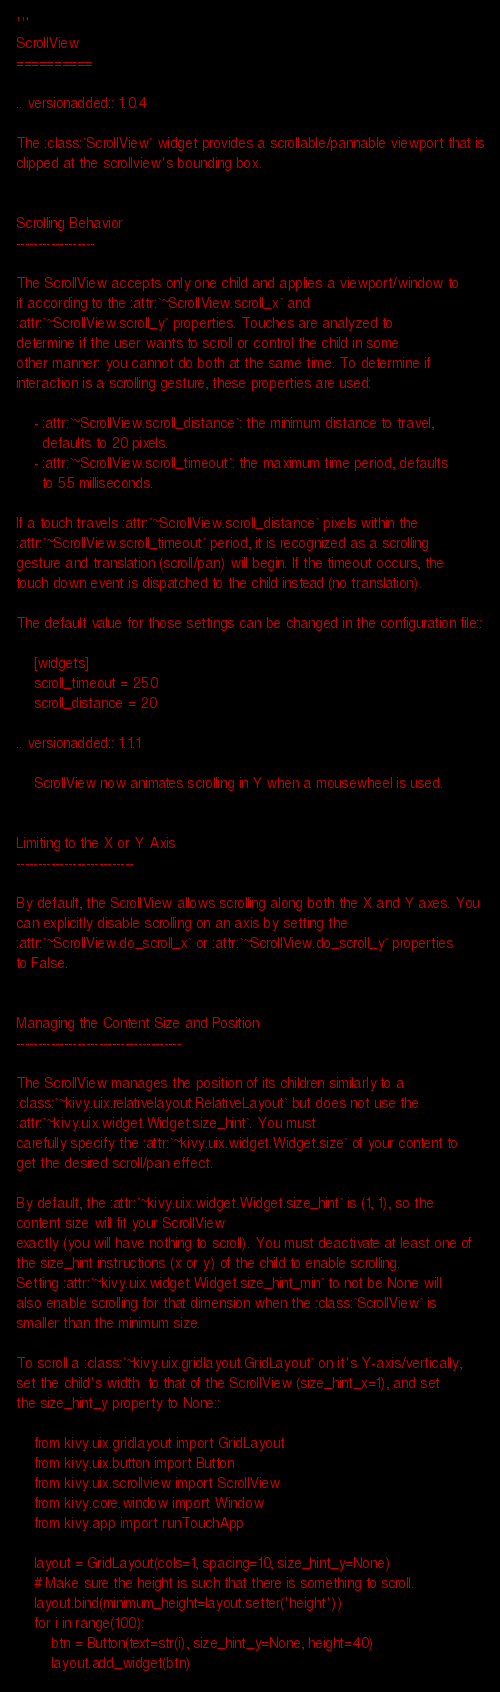<code> <loc_0><loc_0><loc_500><loc_500><_Python_>'''
ScrollView
==========

.. versionadded:: 1.0.4

The :class:`ScrollView` widget provides a scrollable/pannable viewport that is
clipped at the scrollview's bounding box.


Scrolling Behavior
------------------

The ScrollView accepts only one child and applies a viewport/window to
it according to the :attr:`~ScrollView.scroll_x` and
:attr:`~ScrollView.scroll_y` properties. Touches are analyzed to
determine if the user wants to scroll or control the child in some
other manner: you cannot do both at the same time. To determine if
interaction is a scrolling gesture, these properties are used:

    - :attr:`~ScrollView.scroll_distance`: the minimum distance to travel,
      defaults to 20 pixels.
    - :attr:`~ScrollView.scroll_timeout`: the maximum time period, defaults
      to 55 milliseconds.

If a touch travels :attr:`~ScrollView.scroll_distance` pixels within the
:attr:`~ScrollView.scroll_timeout` period, it is recognized as a scrolling
gesture and translation (scroll/pan) will begin. If the timeout occurs, the
touch down event is dispatched to the child instead (no translation).

The default value for those settings can be changed in the configuration file::

    [widgets]
    scroll_timeout = 250
    scroll_distance = 20

.. versionadded:: 1.1.1

    ScrollView now animates scrolling in Y when a mousewheel is used.


Limiting to the X or Y Axis
---------------------------

By default, the ScrollView allows scrolling along both the X and Y axes. You
can explicitly disable scrolling on an axis by setting the
:attr:`~ScrollView.do_scroll_x` or :attr:`~ScrollView.do_scroll_y` properties
to False.


Managing the Content Size and Position
--------------------------------------

The ScrollView manages the position of its children similarly to a
:class:`~kivy.uix.relativelayout.RelativeLayout` but does not use the
:attr:`~kivy.uix.widget.Widget.size_hint`. You must
carefully specify the :attr:`~kivy.uix.widget.Widget.size` of your content to
get the desired scroll/pan effect.

By default, the :attr:`~kivy.uix.widget.Widget.size_hint` is (1, 1), so the
content size will fit your ScrollView
exactly (you will have nothing to scroll). You must deactivate at least one of
the size_hint instructions (x or y) of the child to enable scrolling.
Setting :attr:`~kivy.uix.widget.Widget.size_hint_min` to not be None will
also enable scrolling for that dimension when the :class:`ScrollView` is
smaller than the minimum size.

To scroll a :class:`~kivy.uix.gridlayout.GridLayout` on it's Y-axis/vertically,
set the child's width  to that of the ScrollView (size_hint_x=1), and set
the size_hint_y property to None::

    from kivy.uix.gridlayout import GridLayout
    from kivy.uix.button import Button
    from kivy.uix.scrollview import ScrollView
    from kivy.core.window import Window
    from kivy.app import runTouchApp

    layout = GridLayout(cols=1, spacing=10, size_hint_y=None)
    # Make sure the height is such that there is something to scroll.
    layout.bind(minimum_height=layout.setter('height'))
    for i in range(100):
        btn = Button(text=str(i), size_hint_y=None, height=40)
        layout.add_widget(btn)</code> 